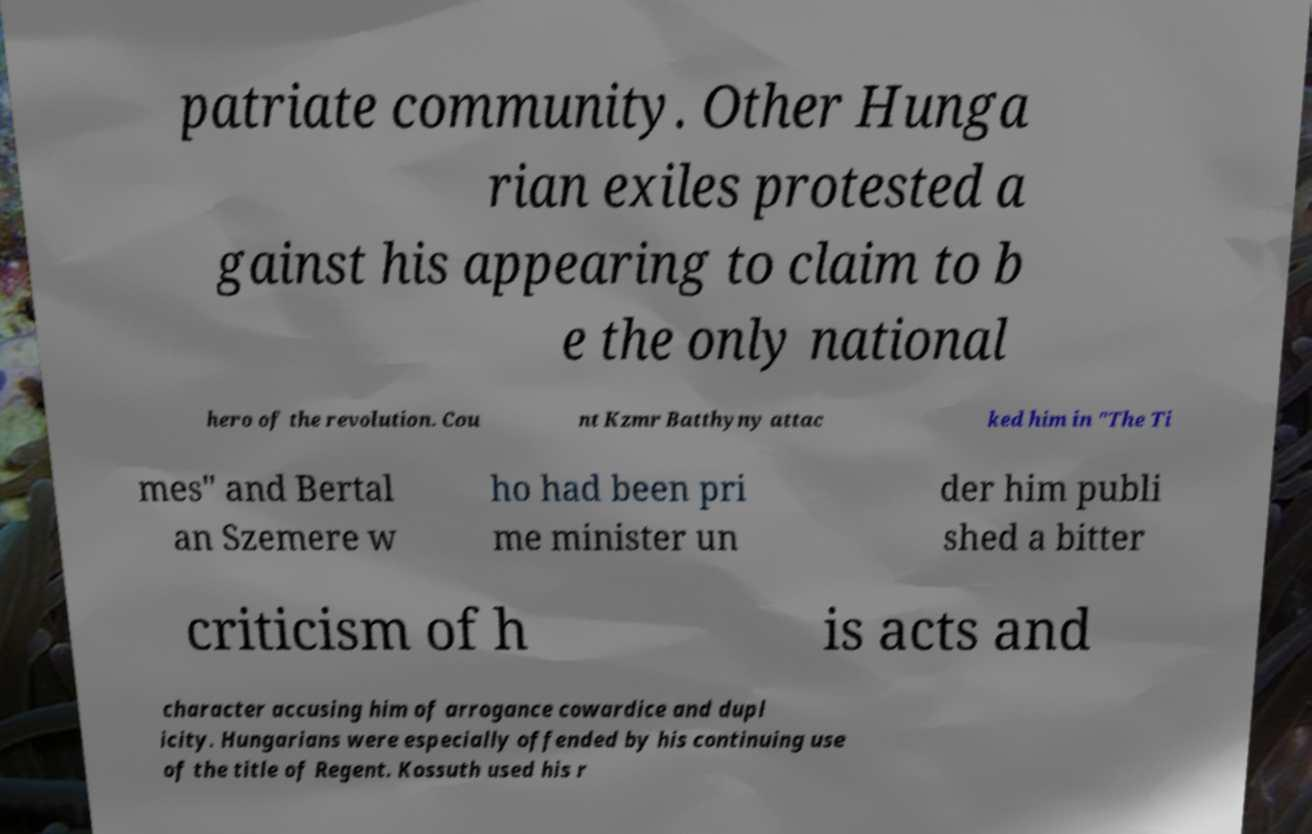For documentation purposes, I need the text within this image transcribed. Could you provide that? patriate community. Other Hunga rian exiles protested a gainst his appearing to claim to b e the only national hero of the revolution. Cou nt Kzmr Batthyny attac ked him in "The Ti mes" and Bertal an Szemere w ho had been pri me minister un der him publi shed a bitter criticism of h is acts and character accusing him of arrogance cowardice and dupl icity. Hungarians were especially offended by his continuing use of the title of Regent. Kossuth used his r 